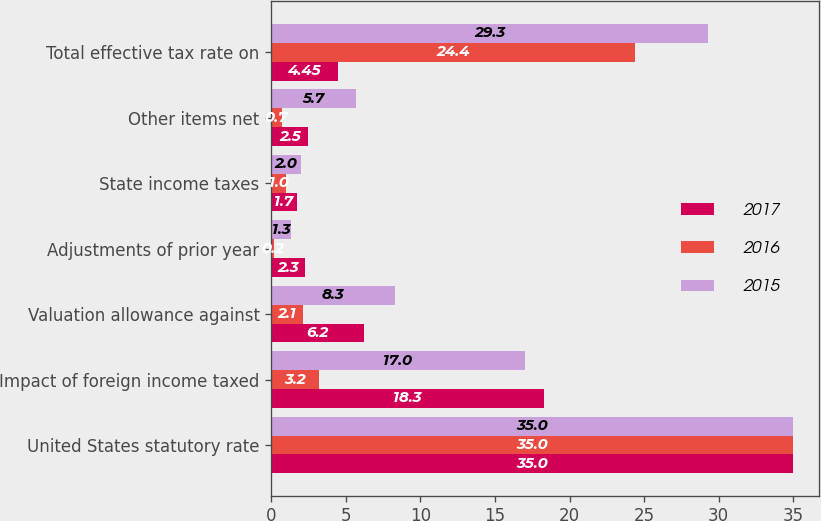Convert chart to OTSL. <chart><loc_0><loc_0><loc_500><loc_500><stacked_bar_chart><ecel><fcel>United States statutory rate<fcel>Impact of foreign income taxed<fcel>Valuation allowance against<fcel>Adjustments of prior year<fcel>State income taxes<fcel>Other items net<fcel>Total effective tax rate on<nl><fcel>2017<fcel>35<fcel>18.3<fcel>6.2<fcel>2.3<fcel>1.7<fcel>2.5<fcel>4.45<nl><fcel>2016<fcel>35<fcel>3.2<fcel>2.1<fcel>0.2<fcel>1<fcel>0.7<fcel>24.4<nl><fcel>2015<fcel>35<fcel>17<fcel>8.3<fcel>1.3<fcel>2<fcel>5.7<fcel>29.3<nl></chart> 